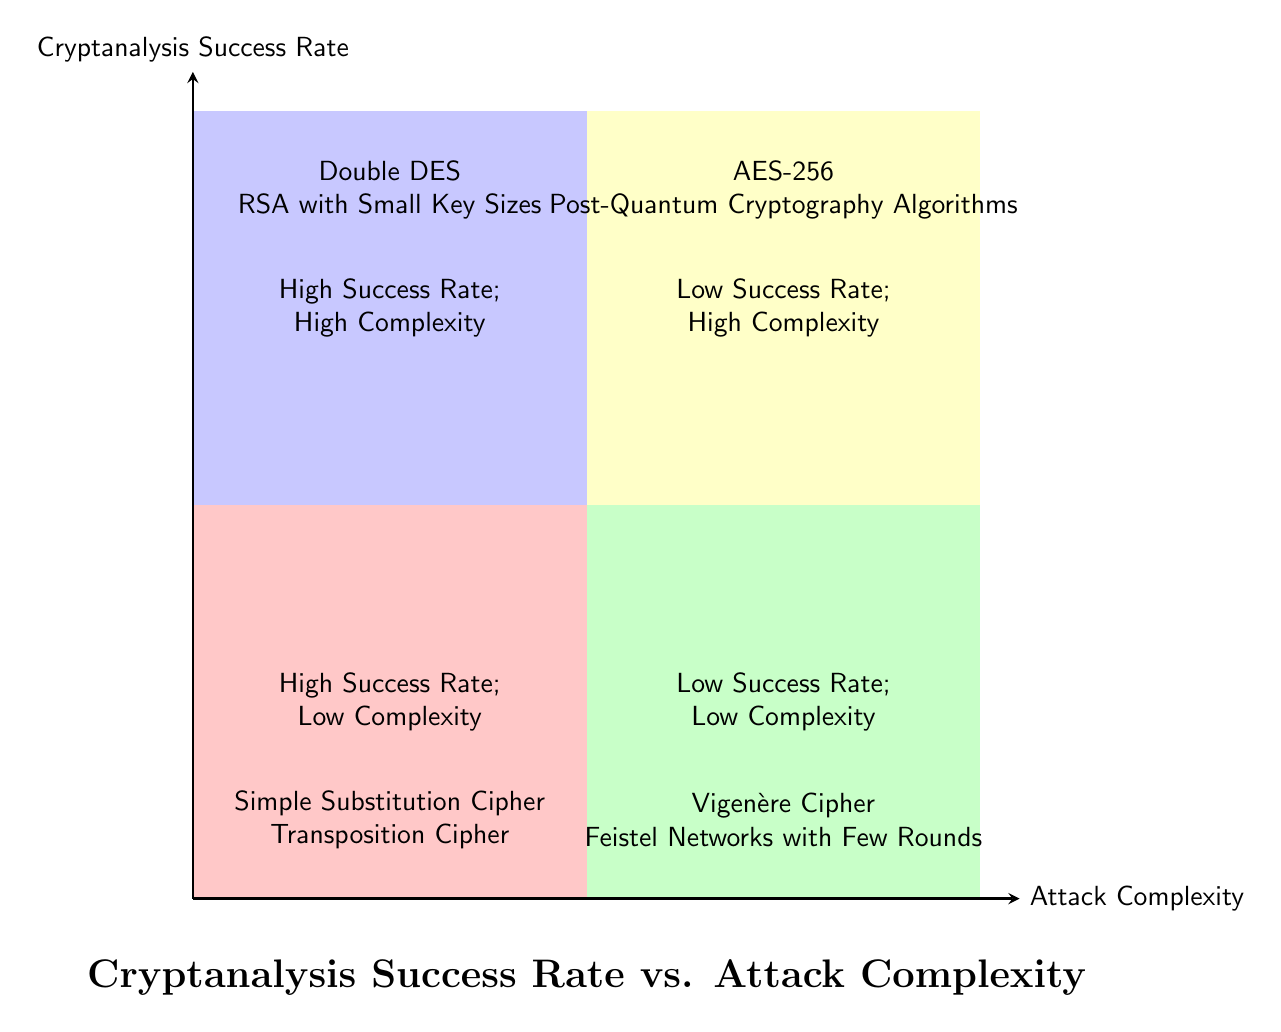What is located in the High Success Rate; Low Complexity quadrant? This quadrant contains the "Simple Substitution Cipher" and "Transposition Cipher". By locating the specific quadrant labeled "High Success Rate; Low Complexity", I can see the cipher types listed there.
Answer: Simple Substitution Cipher, Transposition Cipher Which algorithms fall under the category of High Complexity; Low Success Rate? The quadrant labeled "Low Success Rate; High Complexity" contains "AES-256" and "Post-Quantum Cryptography Algorithms". This is determined by identifying the correct quadrant and reading the contents.
Answer: AES-256, Post-Quantum Cryptography Algorithms How many types of ciphers are classified in the Low Success Rate; Low Complexity quadrant? The "Low Success Rate; Low Complexity" quadrant lists two ciphers: "Vigenère Cipher" and "Feistel Networks with Few Rounds". Count the items within this quadrant confirms there are two types.
Answer: 2 What is the difference in complexity between the algorithms in the High Success Rate; High Complexity quadrant and those in the Low Success Rate; High Complexity quadrant? The algorithms in "High Success Rate; High Complexity" have a "High" complexity while those in "Low Success Rate; High Complexity" have the same "High" complexity. Therefore, their complexities are equal.
Answer: None Which cipher has a higher success rate: Double DES or Vigenère Cipher? The "Double DES" is in the "High Success Rate; High Complexity" quadrant, while the "Vigenère Cipher" is in the "Low Success Rate; Low Complexity" quadrant. Comparing their quadrants reveals that Double DES has a higher success rate.
Answer: Double DES How many quadrants are there in the chart? The chart is divided into four quadrants that can be visually identified based on the arrangement of the axes and labeled sections. Counting these quadrants confirms there are four.
Answer: 4 What are the two quadrants with a High Success Rate? The quadrants labeled "High Success Rate; Low Complexity" and "High Success Rate; High Complexity" represent this category. Identifying the labels on these quadrants indicates their high success rate classification.
Answer: High Success Rate; Low Complexity, High Success Rate; High Complexity What type of algorithm is situated in the quadrant of Low Complexity and High Success Rate? The algorithms in this quadrant are "Simple Substitution Cipher" and "Transposition Cipher". To find the answer, I reference the names listed in the corresponding quadrant.
Answer: Simple Substitution Cipher, Transposition Cipher 